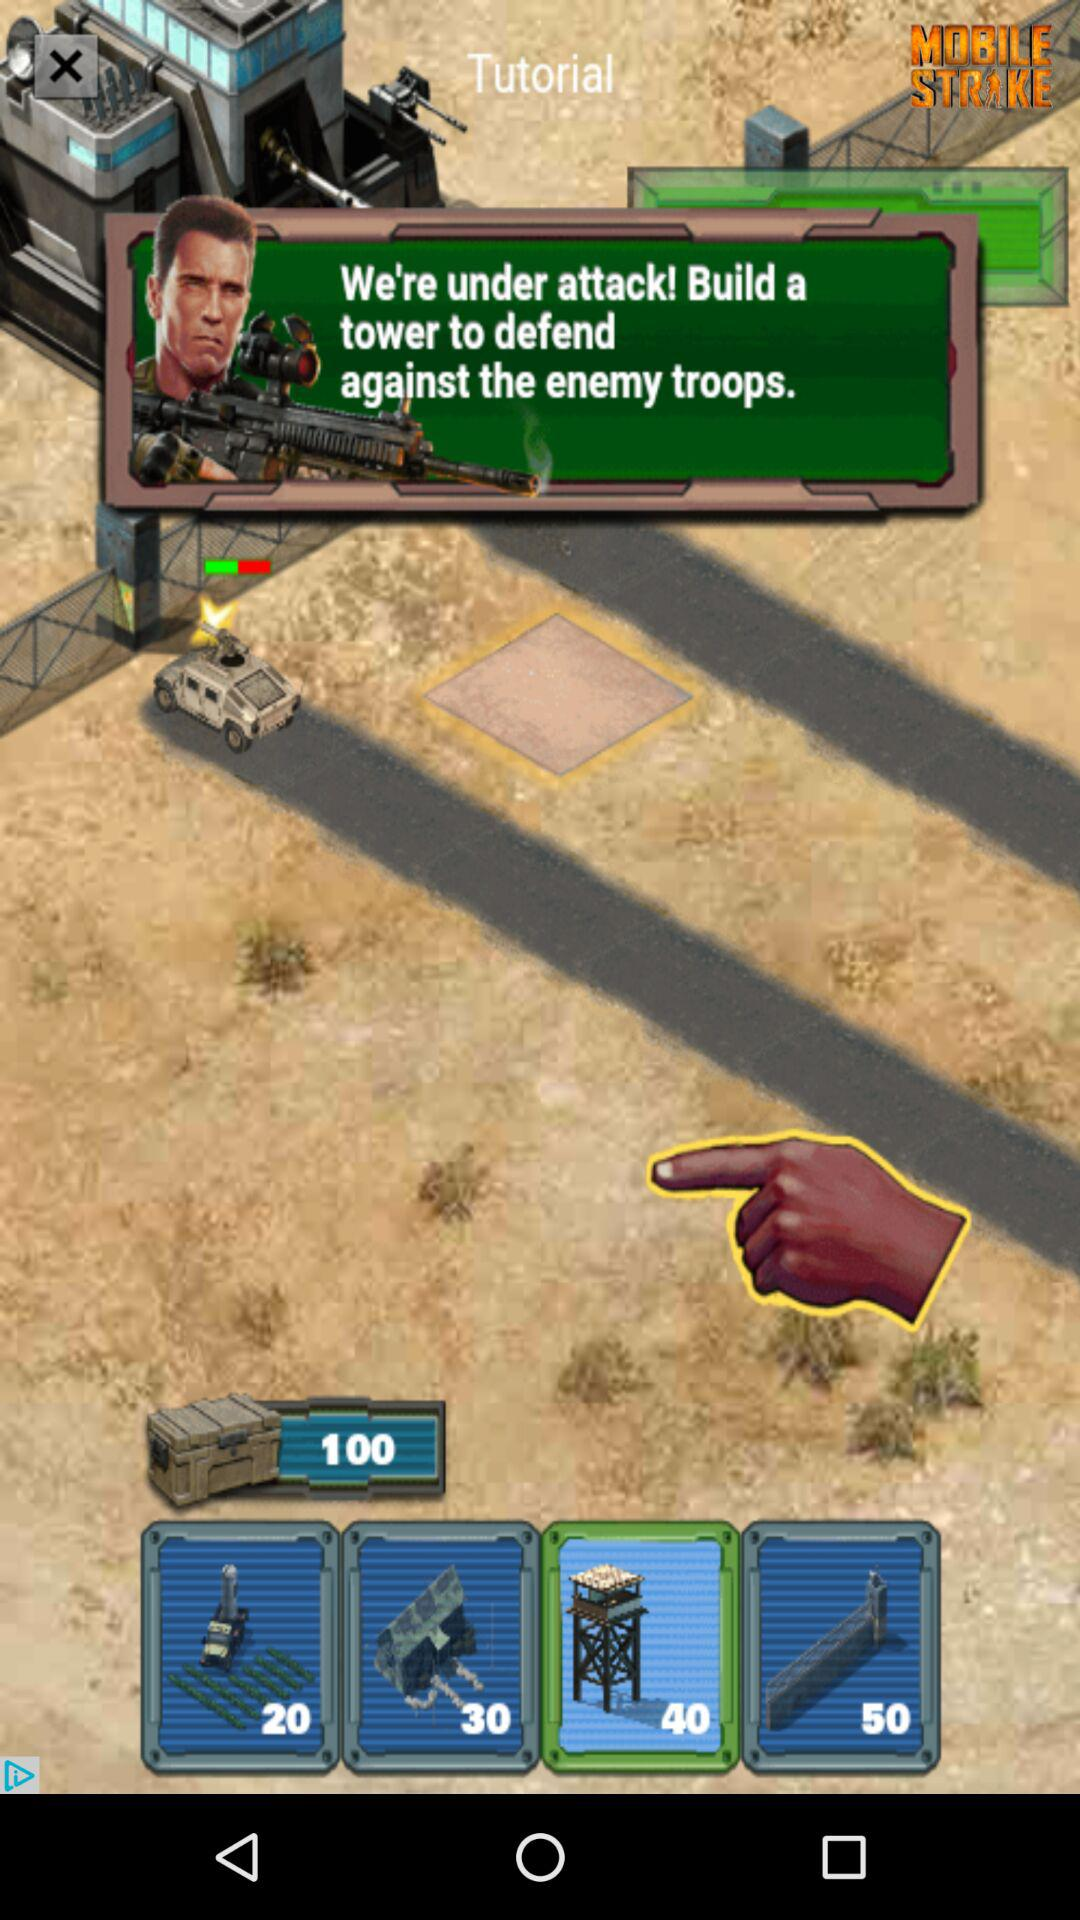How many different towers are available to build?
Answer the question using a single word or phrase. 4 